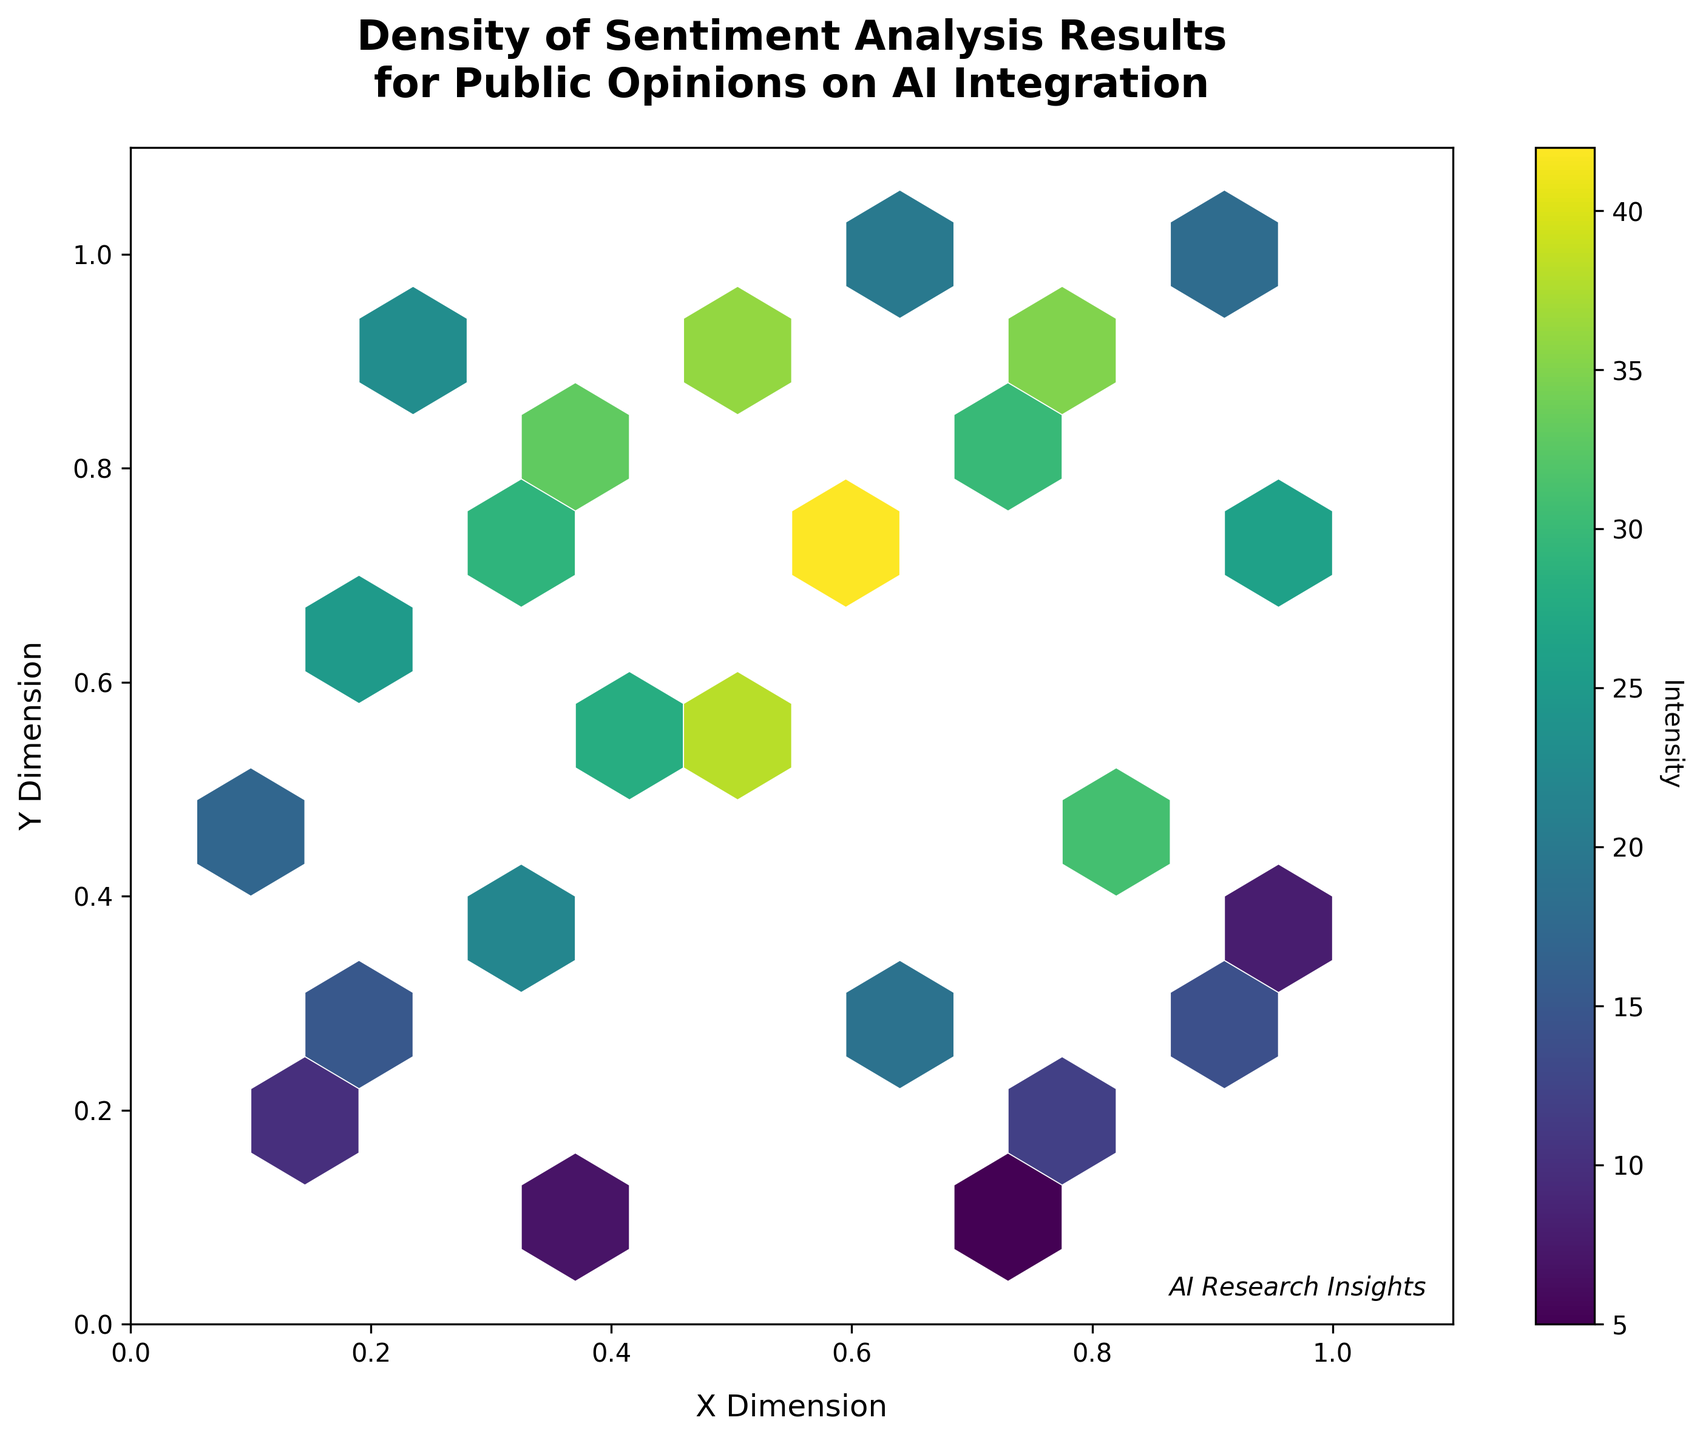What is the title of the hexbin plot? The title of the hexbin plot is prominently displayed at the top of the figure. It reads "Density of Sentiment Analysis Results for Public Opinions on AI Integration."
Answer: Density of Sentiment Analysis Results for Public Opinions on AI Integration What color scheme is used for the hexbin plot? The hexbin plot uses a color scheme that ranges from dark to bright colors, specifically from dark purple to bright yellow-green. This color scheme is known as 'viridis'.
Answer: viridis What is the intensity range represented in the color bar? The color bar on the right side of the hexbin plot shows the intensity range. The range goes from a low value of 5 to a high value of 42.
Answer: 5 to 42 How many data points have been plotted on the hexbin plot, considering the hexagons? Each hexagon on the hexbin plot represents one or more data points. By counting the filled hexagons, you can count the number of data points. In this case, there are 24 data points plotted on the hexbin plot.
Answer: 24 What are the limits of the X and Y axes in the plot? The X and Y axes both have limits that range from 0 to 1.1, as indicated by the axis labels and their respective ticks.
Answer: 0 to 1.1 Which hexagon on the plot has the highest intensity and what is its location? The hexagon with the highest intensity can be identified by the brightest color on the 'viridis' scale. The highest intensity is 42, and its hexagon is located approximately at the coordinates (0.6, 0.7).
Answer: (0.6, 0.7) What is the average intensity of the hexagons located in the first column of the plot? To find the average intensity of the hexagons in the first column, identify their intensities and calculate the average. These hexagons are (0.2, 0.3), (0.1, 0.2), (0.2, 0.6), and (0.2, 0.9) with intensities 15, 10, 25, and 23 respectively. The average is (15 + 10 + 25 + 23) / 4 = 18.25.
Answer: 18.25 Compare the intensities of the hexagons at (0.4, 0.5) and (0.6, 0.3). Which one is higher? The hexagon at (0.4, 0.5) has an intensity of 28, while the hexagon at (0.6, 0.3) has an intensity of 19. Comparing these, the intensity at (0.4, 0.5) is higher.
Answer: (0.4, 0.5) How many hexagons have intensities greater than 30? Identify the hexagons with intensities greater than 30 by checking their colors on the 'viridis' scale. Hexagons at (0.6, 0.7), (0.8, 0.9), (0.5, 0.6), (0.4, 0.8), (0.5, 0.9), and (0.8, 0.5) have intensities greater than 30. This amounts to 6 hexagons.
Answer: 6 What is the hexagon's intensity at the coordinates (1.0, 0.4)? The intensity of the hexagon located at (1.0, 0.4) is easily readable from the figure and corresponds to a value of 8.
Answer: 8 